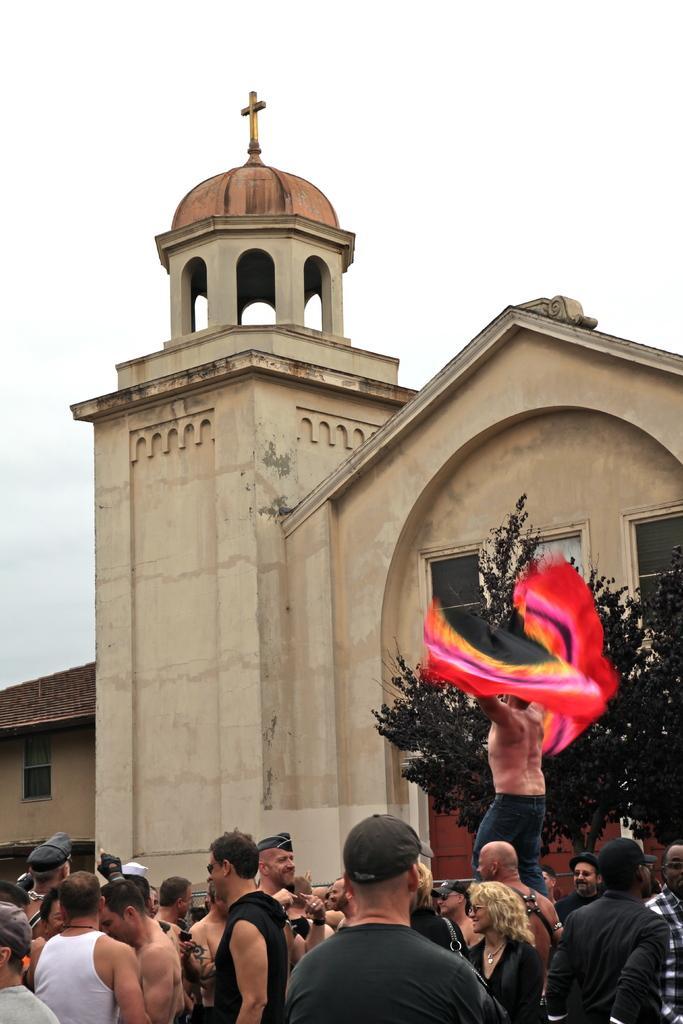In one or two sentences, can you explain what this image depicts? This image consists of many persons. And we can see a person holding the clothes. In the background, there is a building along with a tree. It looks like a church. At the top, there is sky. 